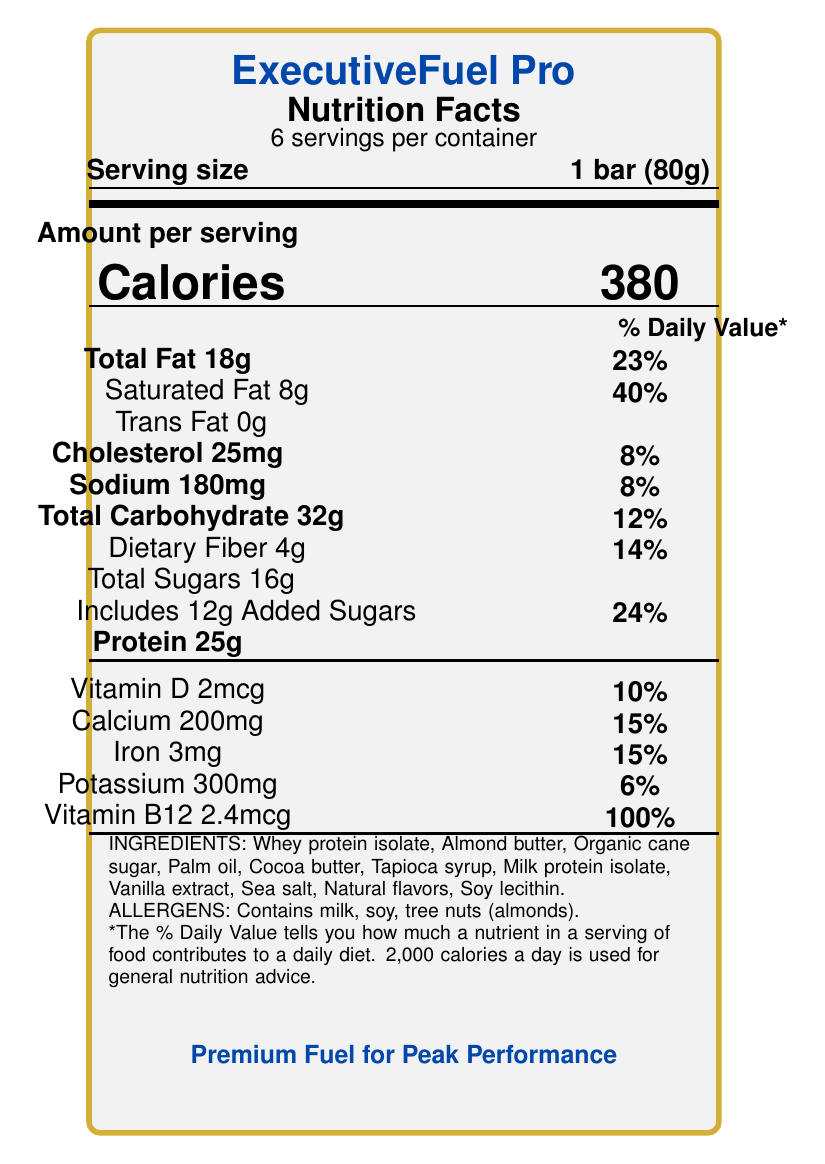what is the serving size? The serving size is indicated next to the phrase "Serving size" at the top of the nutrition facts section.
Answer: 1 bar (80g) how many calories are in one serving? The number of calories per serving is clearly displayed next to the word "Calories" in a large font.
Answer: 380 how much protein is in one bar? The amount of protein per serving is listed as "Protein 25g" in the nutrition section.
Answer: 25g what is the percentage daily value of saturated fat in one bar? The daily value percentage for saturated fat is indicated as "40%" next to "Saturated Fat 8g".
Answer: 40% does the product contain any allergens? The product contains allergens such as milk, soy, and tree nuts (almonds), which are listed under the "ALLERGENS" section at the bottom of the document.
Answer: Yes what is the brand name of this protein bar? The brand name is prominently displayed at the top of the document in a large, bold font.
Answer: ExecutiveFuel Pro how many servings are there per container? The number of servings per container is listed as "6 servings per container" below the main title.
Answer: 6 what is the main source of fat in the bar? A. Almond butter B. Palm oil C. Cocoa butter D. Tapioca syrup From the ingredients list, Almond butter is the likely main source of fat compared to the other options given.
Answer: A which vitamin is present at 100% of the daily value? A. Vitamin D B. Calcium C. Iron D. Vitamin B12 The document lists Vitamin B12 as having 100% of the daily value.
Answer: D is this protein bar suitable for vegans? The protein bar contains several non-vegan ingredients, including whey protein isolate and milk protein isolate.
Answer: No summarize the main features of this protein bar. The summary covers the key nutritional details, intended market, and distinguishing features mentioned in the document, giving a comprehensive overview of the bar.
Answer: The ExecutiveFuel Pro is a high-calorie, high-protein luxury protein bar designed for busy executives. Each bar contains 380 calories, 25g of protein, and various vitamins and minerals. It also contains allergens like milk, soy, and tree nuts. The product promotes sustained energy and focus with premium ingredients. where is the protein bar manufactured? The manufacturing location is not indicated in the Nutrition Facts Label rendered from the provided data.
Answer: Not enough information 